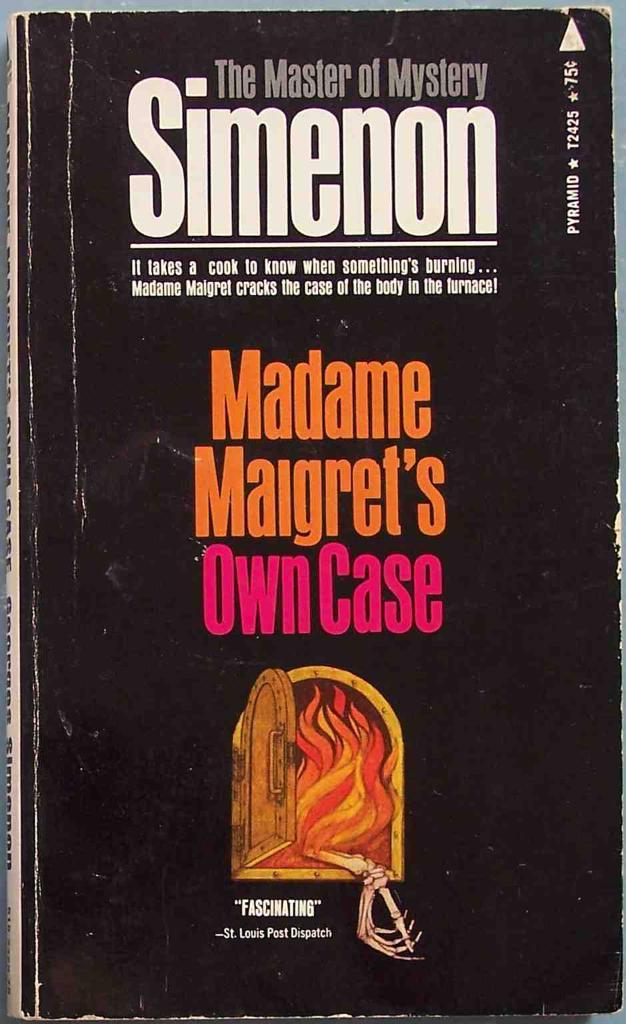Who wrote that book?
Give a very brief answer. Simenon. Simenon is the master of what?
Keep it short and to the point. Mystery. 